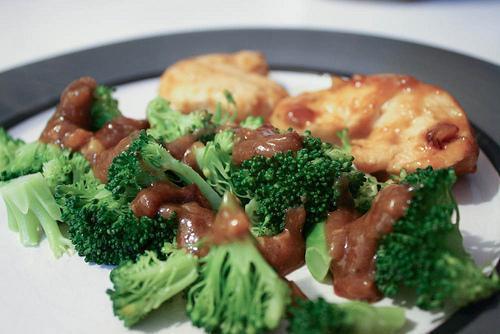How many pieces of meat are there?
Give a very brief answer. 2. 